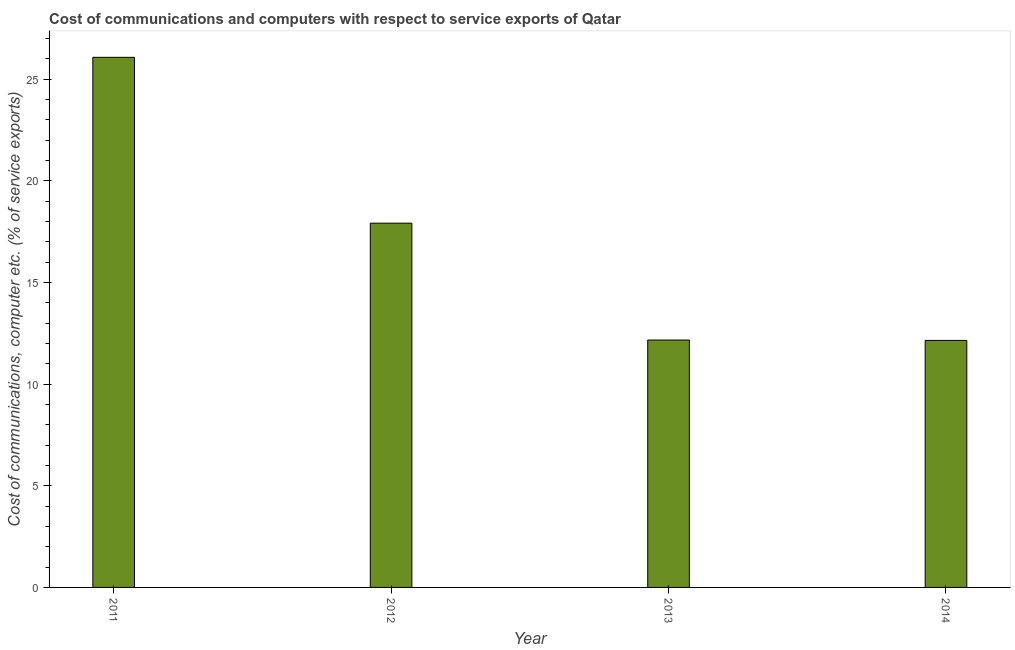Does the graph contain any zero values?
Provide a short and direct response. No. Does the graph contain grids?
Provide a succinct answer. No. What is the title of the graph?
Offer a terse response. Cost of communications and computers with respect to service exports of Qatar. What is the label or title of the Y-axis?
Make the answer very short. Cost of communications, computer etc. (% of service exports). What is the cost of communications and computer in 2013?
Provide a short and direct response. 12.17. Across all years, what is the maximum cost of communications and computer?
Offer a terse response. 26.07. Across all years, what is the minimum cost of communications and computer?
Offer a very short reply. 12.15. In which year was the cost of communications and computer maximum?
Your answer should be compact. 2011. In which year was the cost of communications and computer minimum?
Provide a short and direct response. 2014. What is the sum of the cost of communications and computer?
Provide a short and direct response. 68.3. What is the difference between the cost of communications and computer in 2012 and 2013?
Offer a very short reply. 5.75. What is the average cost of communications and computer per year?
Your answer should be compact. 17.07. What is the median cost of communications and computer?
Your answer should be compact. 15.04. What is the ratio of the cost of communications and computer in 2012 to that in 2013?
Keep it short and to the point. 1.47. What is the difference between the highest and the second highest cost of communications and computer?
Provide a succinct answer. 8.15. Is the sum of the cost of communications and computer in 2011 and 2014 greater than the maximum cost of communications and computer across all years?
Keep it short and to the point. Yes. What is the difference between the highest and the lowest cost of communications and computer?
Provide a succinct answer. 13.92. In how many years, is the cost of communications and computer greater than the average cost of communications and computer taken over all years?
Ensure brevity in your answer.  2. How many bars are there?
Provide a succinct answer. 4. What is the Cost of communications, computer etc. (% of service exports) of 2011?
Make the answer very short. 26.07. What is the Cost of communications, computer etc. (% of service exports) of 2012?
Ensure brevity in your answer.  17.91. What is the Cost of communications, computer etc. (% of service exports) in 2013?
Provide a short and direct response. 12.17. What is the Cost of communications, computer etc. (% of service exports) in 2014?
Your response must be concise. 12.15. What is the difference between the Cost of communications, computer etc. (% of service exports) in 2011 and 2012?
Offer a very short reply. 8.16. What is the difference between the Cost of communications, computer etc. (% of service exports) in 2011 and 2013?
Offer a very short reply. 13.9. What is the difference between the Cost of communications, computer etc. (% of service exports) in 2011 and 2014?
Give a very brief answer. 13.92. What is the difference between the Cost of communications, computer etc. (% of service exports) in 2012 and 2013?
Make the answer very short. 5.75. What is the difference between the Cost of communications, computer etc. (% of service exports) in 2012 and 2014?
Provide a short and direct response. 5.77. What is the difference between the Cost of communications, computer etc. (% of service exports) in 2013 and 2014?
Offer a terse response. 0.02. What is the ratio of the Cost of communications, computer etc. (% of service exports) in 2011 to that in 2012?
Provide a short and direct response. 1.46. What is the ratio of the Cost of communications, computer etc. (% of service exports) in 2011 to that in 2013?
Make the answer very short. 2.14. What is the ratio of the Cost of communications, computer etc. (% of service exports) in 2011 to that in 2014?
Make the answer very short. 2.15. What is the ratio of the Cost of communications, computer etc. (% of service exports) in 2012 to that in 2013?
Provide a short and direct response. 1.47. What is the ratio of the Cost of communications, computer etc. (% of service exports) in 2012 to that in 2014?
Your answer should be very brief. 1.48. 